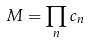<formula> <loc_0><loc_0><loc_500><loc_500>M = \prod _ { n } c _ { n }</formula> 